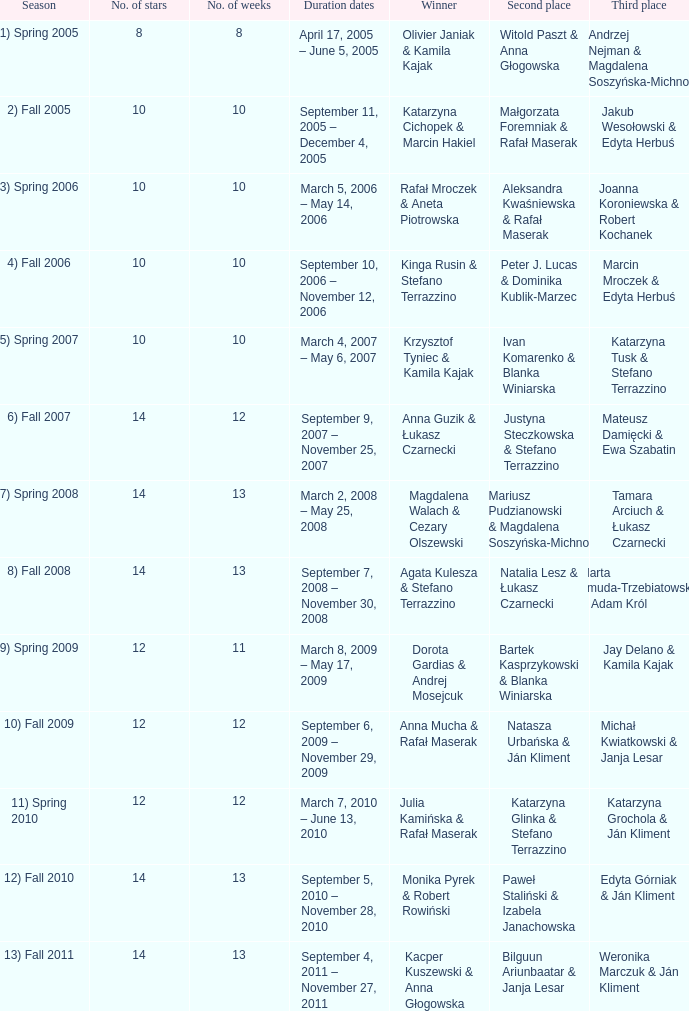Give me the full table as a dictionary. {'header': ['Season', 'No. of stars', 'No. of weeks', 'Duration dates', 'Winner', 'Second place', 'Third place'], 'rows': [['1) Spring 2005', '8', '8', 'April 17, 2005 – June 5, 2005', 'Olivier Janiak & Kamila Kajak', 'Witold Paszt & Anna Głogowska', 'Andrzej Nejman & Magdalena Soszyńska-Michno'], ['2) Fall 2005', '10', '10', 'September 11, 2005 – December 4, 2005', 'Katarzyna Cichopek & Marcin Hakiel', 'Małgorzata Foremniak & Rafał Maserak', 'Jakub Wesołowski & Edyta Herbuś'], ['3) Spring 2006', '10', '10', 'March 5, 2006 – May 14, 2006', 'Rafał Mroczek & Aneta Piotrowska', 'Aleksandra Kwaśniewska & Rafał Maserak', 'Joanna Koroniewska & Robert Kochanek'], ['4) Fall 2006', '10', '10', 'September 10, 2006 – November 12, 2006', 'Kinga Rusin & Stefano Terrazzino', 'Peter J. Lucas & Dominika Kublik-Marzec', 'Marcin Mroczek & Edyta Herbuś'], ['5) Spring 2007', '10', '10', 'March 4, 2007 – May 6, 2007', 'Krzysztof Tyniec & Kamila Kajak', 'Ivan Komarenko & Blanka Winiarska', 'Katarzyna Tusk & Stefano Terrazzino'], ['6) Fall 2007', '14', '12', 'September 9, 2007 – November 25, 2007', 'Anna Guzik & Łukasz Czarnecki', 'Justyna Steczkowska & Stefano Terrazzino', 'Mateusz Damięcki & Ewa Szabatin'], ['7) Spring 2008', '14', '13', 'March 2, 2008 – May 25, 2008', 'Magdalena Walach & Cezary Olszewski', 'Mariusz Pudzianowski & Magdalena Soszyńska-Michno', 'Tamara Arciuch & Łukasz Czarnecki'], ['8) Fall 2008', '14', '13', 'September 7, 2008 – November 30, 2008', 'Agata Kulesza & Stefano Terrazzino', 'Natalia Lesz & Łukasz Czarnecki', 'Marta Żmuda-Trzebiatowska & Adam Król'], ['9) Spring 2009', '12', '11', 'March 8, 2009 – May 17, 2009', 'Dorota Gardias & Andrej Mosejcuk', 'Bartek Kasprzykowski & Blanka Winiarska', 'Jay Delano & Kamila Kajak'], ['10) Fall 2009', '12', '12', 'September 6, 2009 – November 29, 2009', 'Anna Mucha & Rafał Maserak', 'Natasza Urbańska & Ján Kliment', 'Michał Kwiatkowski & Janja Lesar'], ['11) Spring 2010', '12', '12', 'March 7, 2010 – June 13, 2010', 'Julia Kamińska & Rafał Maserak', 'Katarzyna Glinka & Stefano Terrazzino', 'Katarzyna Grochola & Ján Kliment'], ['12) Fall 2010', '14', '13', 'September 5, 2010 – November 28, 2010', 'Monika Pyrek & Robert Rowiński', 'Paweł Staliński & Izabela Janachowska', 'Edyta Górniak & Ján Kliment'], ['13) Fall 2011', '14', '13', 'September 4, 2011 – November 27, 2011', 'Kacper Kuszewski & Anna Głogowska', 'Bilguun Ariunbaatar & Janja Lesar', 'Weronika Marczuk & Ján Kliment']]} Who got second place when the winners were rafał mroczek & aneta piotrowska? Aleksandra Kwaśniewska & Rafał Maserak. 